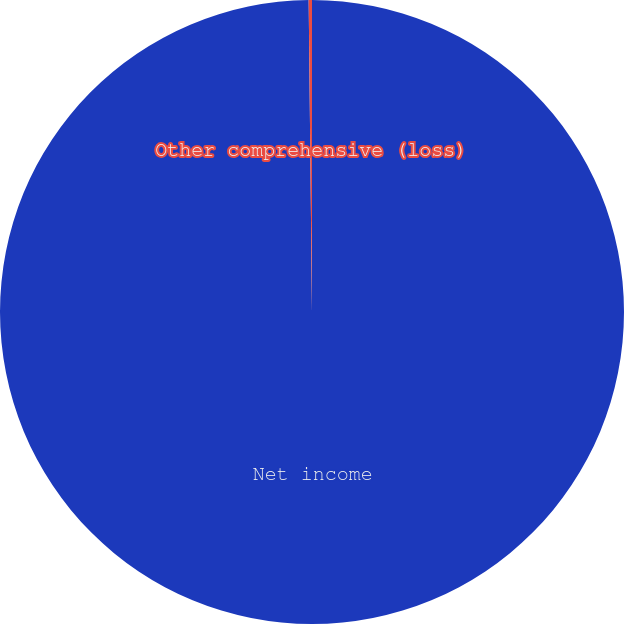Convert chart to OTSL. <chart><loc_0><loc_0><loc_500><loc_500><pie_chart><fcel>Net income<fcel>Other comprehensive (loss)<nl><fcel>99.83%<fcel>0.17%<nl></chart> 